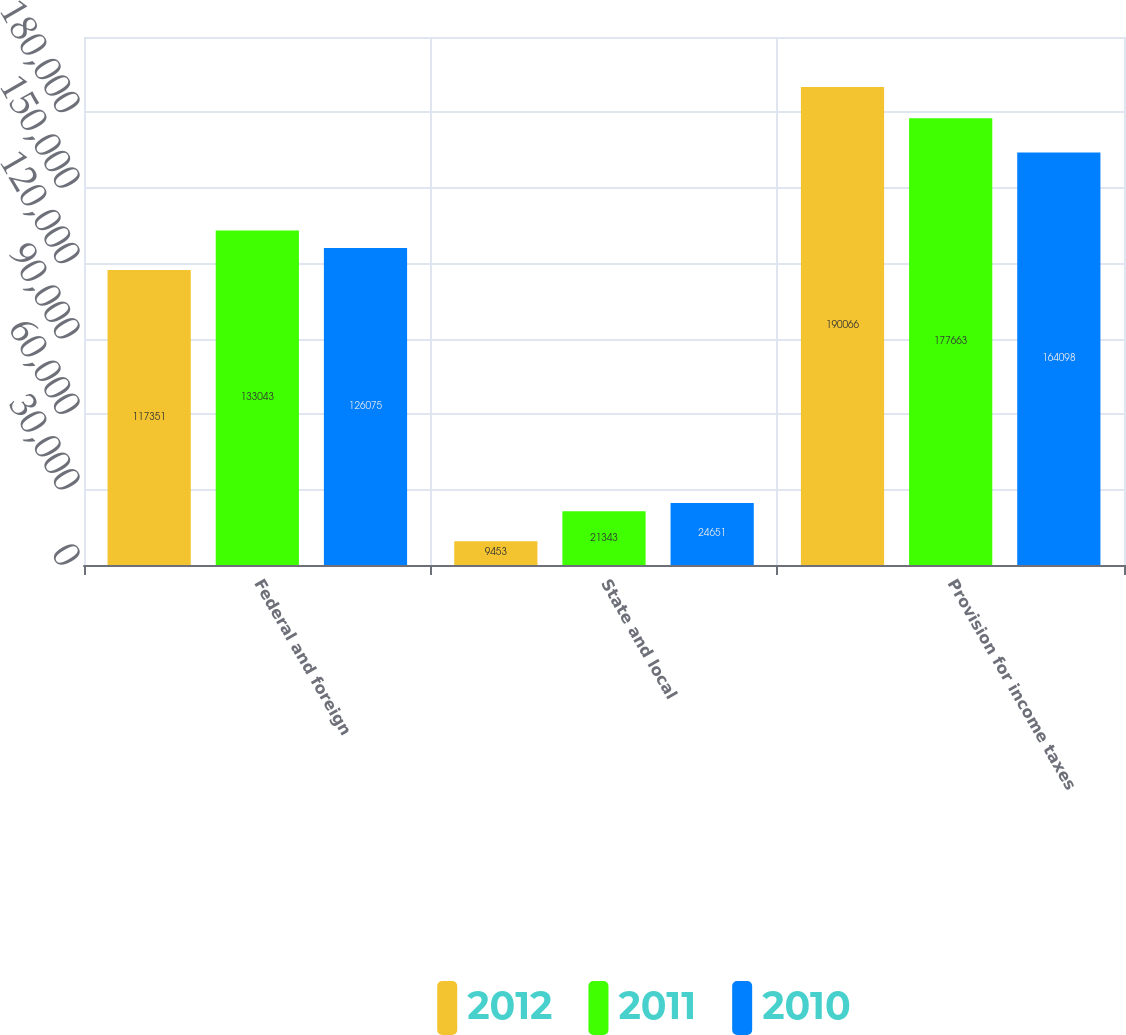Convert chart to OTSL. <chart><loc_0><loc_0><loc_500><loc_500><stacked_bar_chart><ecel><fcel>Federal and foreign<fcel>State and local<fcel>Provision for income taxes<nl><fcel>2012<fcel>117351<fcel>9453<fcel>190066<nl><fcel>2011<fcel>133043<fcel>21343<fcel>177663<nl><fcel>2010<fcel>126075<fcel>24651<fcel>164098<nl></chart> 